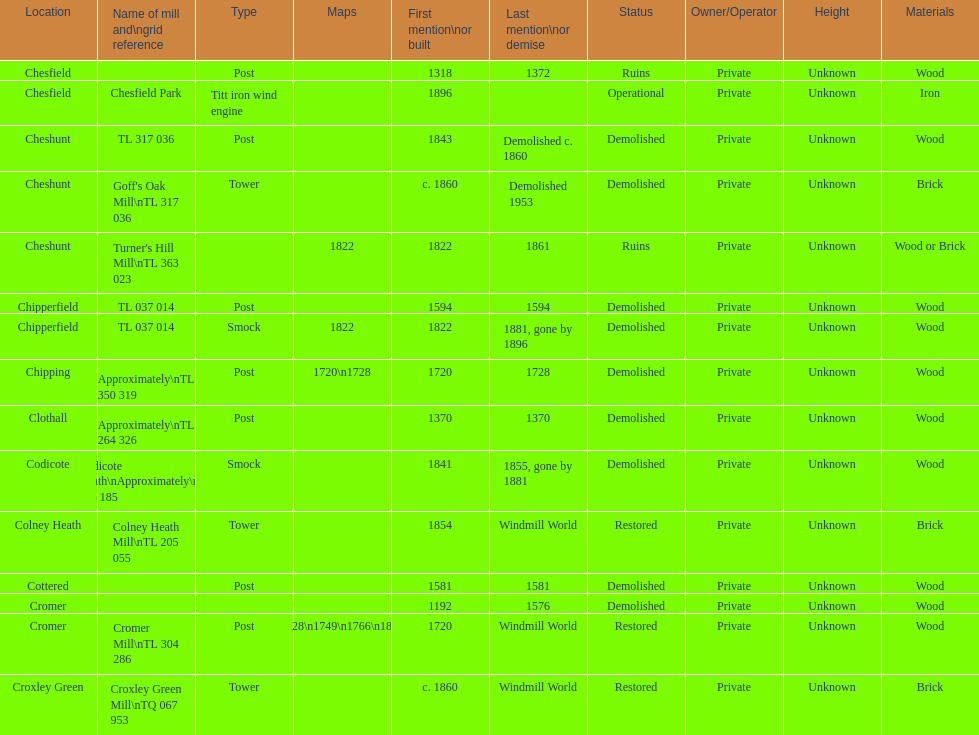What is the name of the only "c" mill located in colney health? Colney Heath Mill. Parse the full table. {'header': ['Location', 'Name of mill and\\ngrid reference', 'Type', 'Maps', 'First mention\\nor built', 'Last mention\\nor demise', 'Status', 'Owner/Operator', 'Height', 'Materials'], 'rows': [['Chesfield', '', 'Post', '', '1318', '1372', 'Ruins', 'Private', 'Unknown', 'Wood'], ['Chesfield', 'Chesfield Park', 'Titt iron wind engine', '', '1896', '', 'Operational', 'Private', 'Unknown', 'Iron'], ['Cheshunt', 'TL 317 036', 'Post', '', '1843', 'Demolished c. 1860', 'Demolished', 'Private', 'Unknown', 'Wood'], ['Cheshunt', "Goff's Oak Mill\\nTL 317 036", 'Tower', '', 'c. 1860', 'Demolished 1953', 'Demolished', 'Private', 'Unknown', 'Brick'], ['Cheshunt', "Turner's Hill Mill\\nTL 363 023", '', '1822', '1822', '1861', 'Ruins', 'Private', 'Unknown', 'Wood or Brick'], ['Chipperfield', 'TL 037 014', 'Post', '', '1594', '1594', 'Demolished', 'Private', 'Unknown', 'Wood'], ['Chipperfield', 'TL 037 014', 'Smock', '1822', '1822', '1881, gone by 1896', 'Demolished', 'Private', 'Unknown', 'Wood'], ['Chipping', 'Approximately\\nTL 350 319', 'Post', '1720\\n1728', '1720', '1728', 'Demolished', 'Private', 'Unknown', 'Wood'], ['Clothall', 'Approximately\\nTL 264 326', 'Post', '', '1370', '1370', 'Demolished', 'Private', 'Unknown', 'Wood'], ['Codicote', 'Codicote Heath\\nApproximately\\nTL 206 185', 'Smock', '', '1841', '1855, gone by 1881', 'Demolished', 'Private', 'Unknown', 'Wood'], ['Colney Heath', 'Colney Heath Mill\\nTL 205 055', 'Tower', '', '1854', 'Windmill World', 'Restored', 'Private', 'Unknown', 'Brick'], ['Cottered', '', 'Post', '', '1581', '1581', 'Demolished', 'Private', 'Unknown', 'Wood'], ['Cromer', '', '', '', '1192', '1576', 'Demolished', 'Private', 'Unknown', 'Wood'], ['Cromer', 'Cromer Mill\\nTL 304 286', 'Post', '1720\\n1728\\n1749\\n1766\\n1800\\n1822', '1720', 'Windmill World', 'Restored', 'Private', 'Unknown', 'Wood'], ['Croxley Green', 'Croxley Green Mill\\nTQ 067 953', 'Tower', '', 'c. 1860', 'Windmill World', 'Restored', 'Private', 'Unknown', 'Brick']]} 